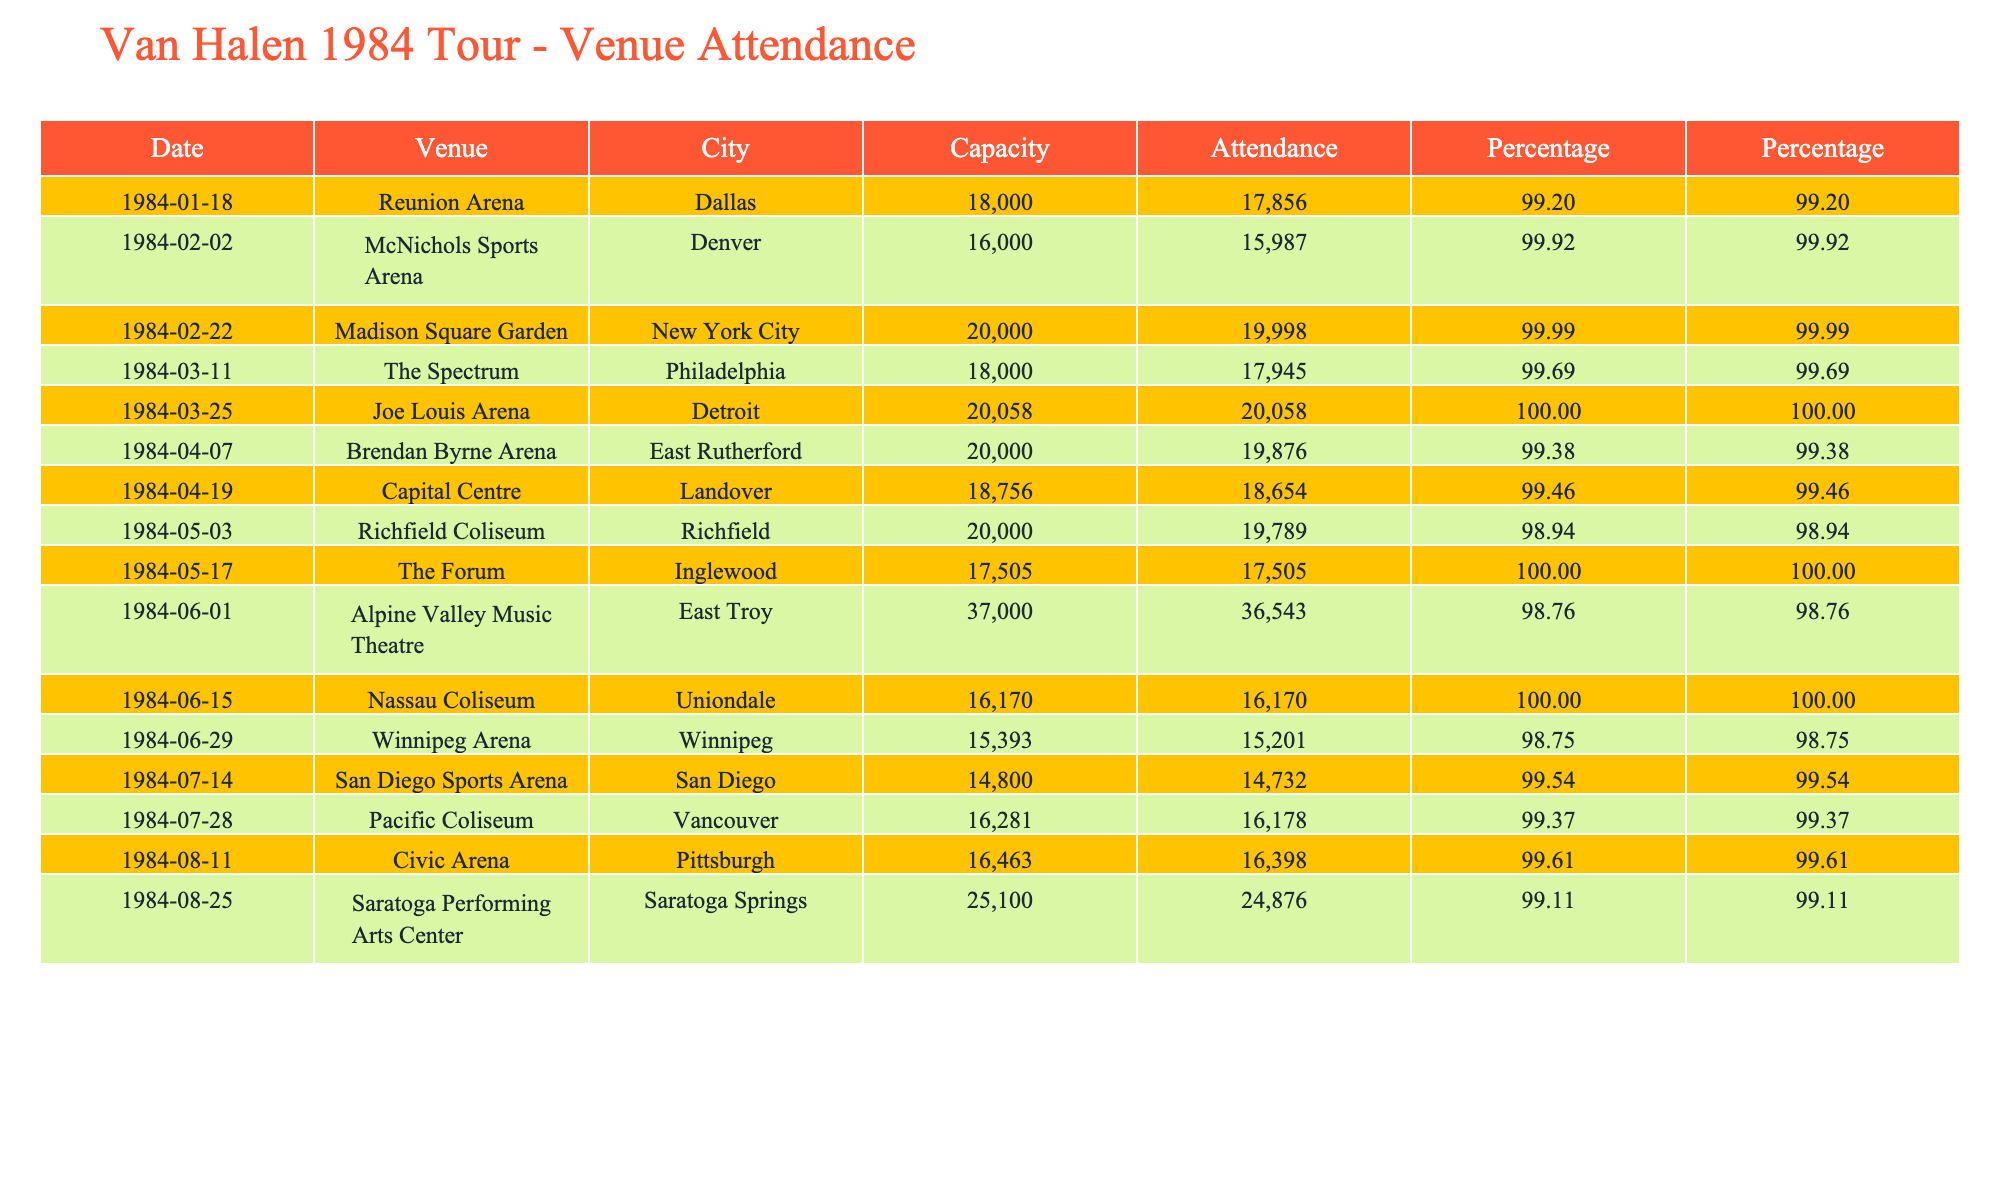What was the highest attendance at a Van Halen concert during the 1984 tour? The table shows the attendance figures, and the highest figure listed is 20,058 for the concert at Joe Louis Arena in Detroit on March 25, 1984.
Answer: 20058 How many concerts had an attendance of over 18,000? By reviewing the attendance figures, we find that there are 8 concerts with attendance over 18,000: Reunion Arena, Madison Square Garden, Joe Louis Arena, Brendan Byrne Arena, Richfield Coliseum, Alpine Valley Music Theatre, Nassau Coliseum, and Saratoga Performing Arts Center.
Answer: 8 What percentage of the capacity was filled at The Spectrum in Philadelphia? The attendance at The Spectrum was 17,945 and the capacity was 18,000. Calculating the percentage gives (17,945 / 18,000) * 100 = 99.72%.
Answer: 99.72% Did any venue have an attendance equal to its capacity? Looking at the attendance figures compared to the capacities, Joe Louis Arena had an attendance equal to its capacity of 20,058. Therefore, there was at least one instance where attendance matched capacity.
Answer: Yes Which venue had the largest capacity and what was the attendance? The venue with the largest capacity was Alpine Valley Music Theatre with a capacity of 37,000, and its attendance was 36,543.
Answer: 37000, 36543 How does the attendance at Madison Square Garden compare to its capacity? The attendance at Madison Square Garden was 19,998 with a capacity of 20,000. This indicates that it was very close to full, just 2 short of the total capacity, which can be calculated as (19,998 / 20,000) * 100 = 99.99%.
Answer: 19,998 was very close to its capacity What was the average attendance for venues with a capacity of 20,000? The venues with a capacity of 20,000 are Madison Square Garden, Brendan Byrne Arena, and Richfield Coliseum, with attendances of 19,998, 19,876, and 19,789 respectively. The total attendance for these three venues is 19,998 + 19,876 + 19,789 = 59,663. Dividing by 3 gives an average of 59,663 / 3 = 19,887.67.
Answer: 19887.67 What is the difference in attendance between the highest and lowest attended concert on the tour? The highest attendance was 20,058 at Joe Louis Arena, and the lowest was 15,201 at Winnipeg Arena. The difference is 20,058 - 15,201 = 4,857.
Answer: 4857 Which venue had the lowest capacity, and how many attended that concert? The venue with the lowest capacity was San Diego Sports Arena, which had a capacity of 14,800 and an attendance of 14,732.
Answer: 14800, 14732 Did every concert on the tour fill at least 90% of their capacity? By evaluating the attendance and capacity percentages, we notice that San Diego Sports Arena had an attendance of 14,732 out of 14,800, which is approximately 99.54%. Hence, all concerts exceeded 90% capacity.
Answer: Yes 